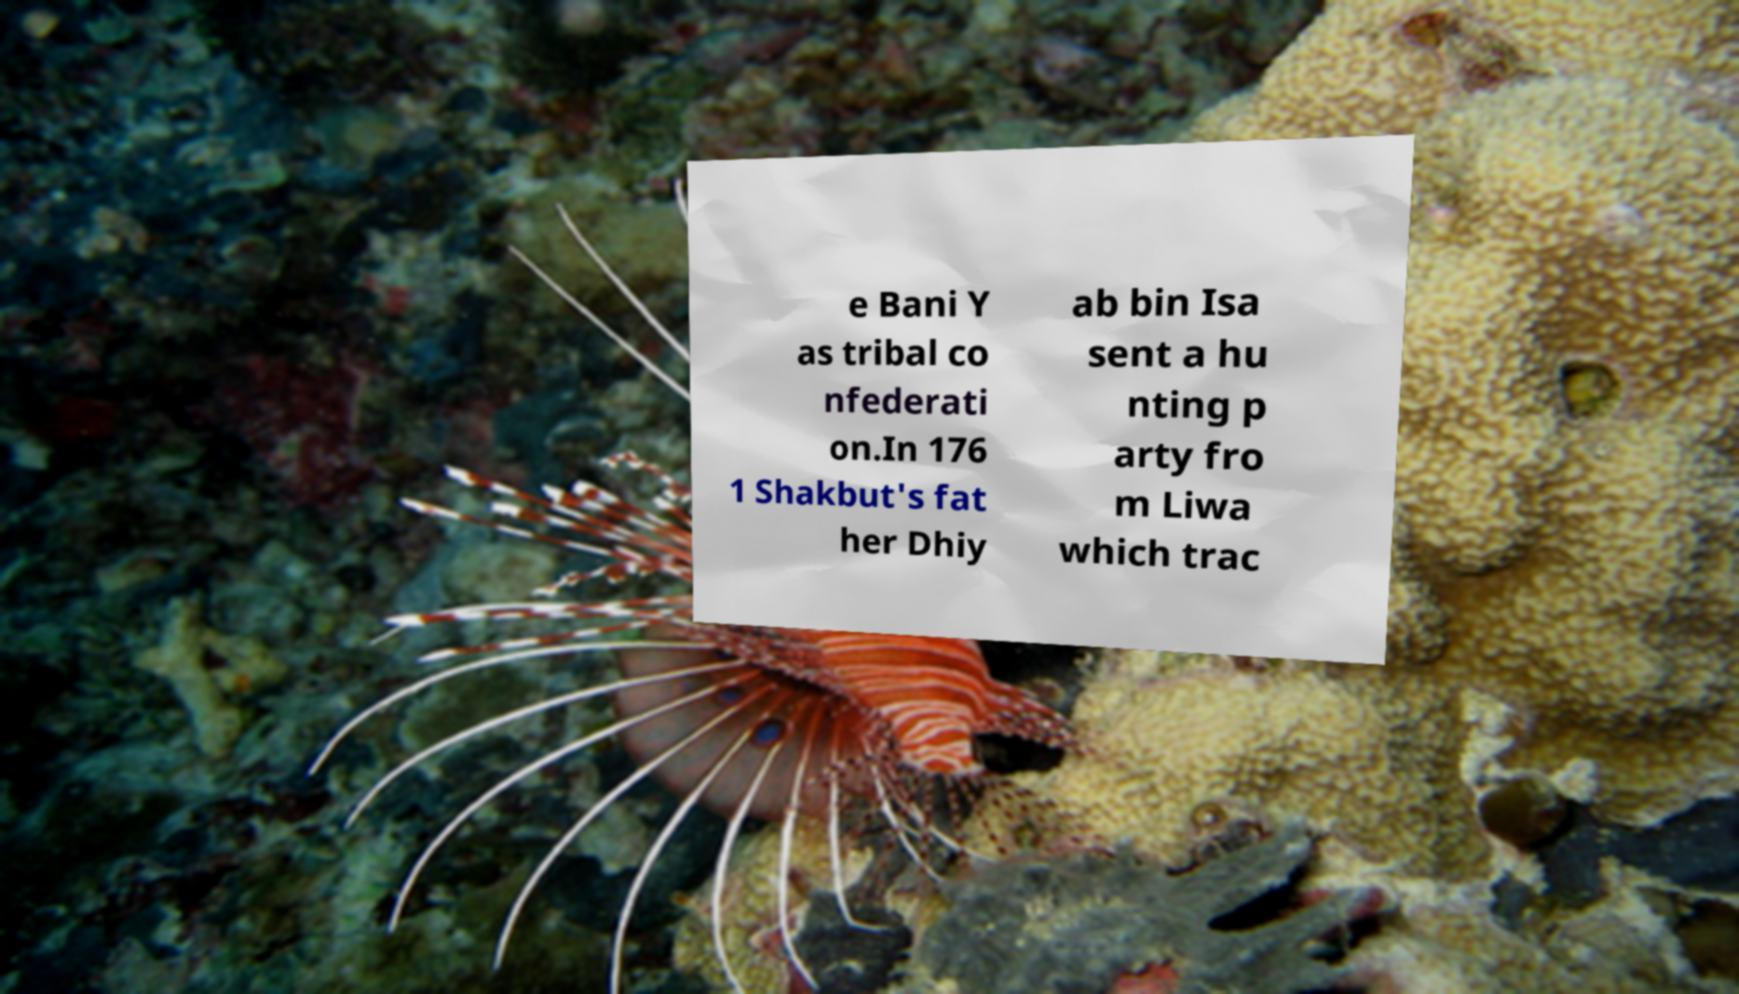Please identify and transcribe the text found in this image. e Bani Y as tribal co nfederati on.In 176 1 Shakbut's fat her Dhiy ab bin Isa sent a hu nting p arty fro m Liwa which trac 